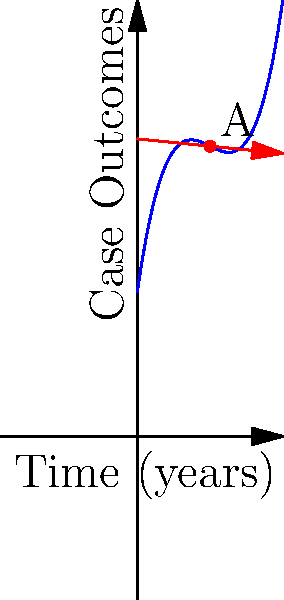In the graph above, the curve represents the trend of favorable legal case outcomes over time for a particular law firm. Point A on the curve corresponds to the 5-year mark. Calculate the instantaneous rate of change in case outcomes at point A. To find the instantaneous rate of change at point A, we need to calculate the slope of the tangent line at that point. Here's how we can do it:

1) The curve is represented by the function $f(x) = 0.1x^3 - 1.5x^2 + 7x + 10$, where $x$ is time in years and $f(x)$ is the number of favorable case outcomes.

2) To find the slope of the tangent line, we need to find the derivative of $f(x)$ and evaluate it at $x = 5$ (since point A is at the 5-year mark).

3) The derivative of $f(x)$ is:
   $f'(x) = 0.3x^2 - 3x + 7$

4) Now, let's evaluate $f'(5)$:
   $f'(5) = 0.3(5)^2 - 3(5) + 7$
   $= 0.3(25) - 15 + 7$
   $= 7.5 - 15 + 7$
   $= -0.5$

5) Therefore, the slope of the tangent line at point A is -0.5.

This means that at the 5-year mark, the instantaneous rate of change in favorable case outcomes is -0.5 cases per year.
Answer: $-0.5$ cases per year 